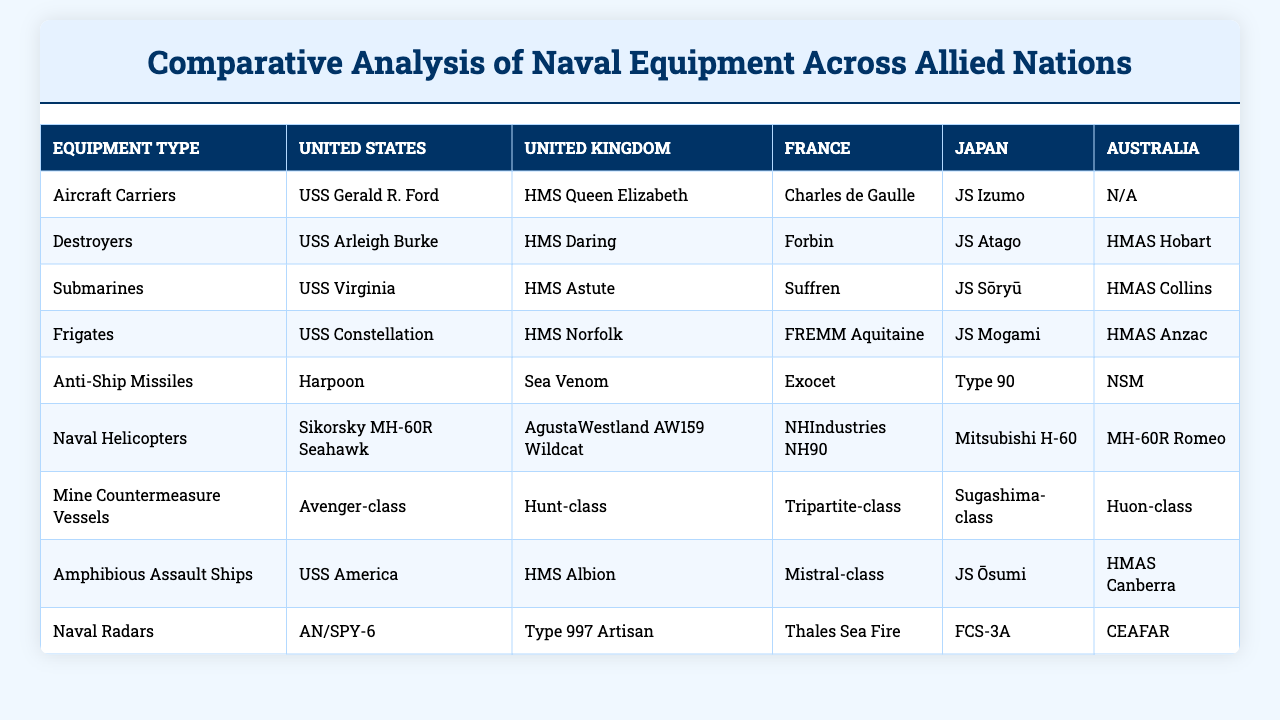What is the aircraft carrier of the United Kingdom? The table indicates that the United Kingdom's aircraft carrier is HMS Queen Elizabeth.
Answer: HMS Queen Elizabeth Which nation has the most types of destroyers listed? Each allied nation has one type of destroyer listed in the table, so there are no differences in the number of destroyers among the nations.
Answer: None (equal amount) Does Australia have an aircraft carrier? The table shows that Australia's entry for aircraft carriers is listed as N/A, indicating they do not possess one.
Answer: No What is the anti-ship missile used by France? Referring to the table, the anti-ship missile specified for France is Exocet.
Answer: Exocet Which country uses the USS Arleigh Burke? According to the information presented, the USS Arleigh Burke is associated with the United States.
Answer: United States Identify the helicopter utilized by Japan. The table lists the Mitsubishi H-60 as Japan's naval helicopter.
Answer: Mitsubishi H-60 Out of the listed nations, which has the most advanced radar system as per the table? The radar systems are different for each country, but each country's entry is listed in the table, and there is no standardized "advanced" measure provided. Thus, no single nation can be determined as having the most advanced radar system based solely on the names listed.
Answer: Cannot determine What is the difference in type of submarines between the United States and Australia? The United States has the USS Virginia as their submarine while Australia has HMAS Collins. Therefore, the difference lies in the specific model used, indicating diversity in submarine technology.
Answer: Different models If you add the number of ship types listed for each country, what will be the total? Each country has 8 types of naval equipment listed in the table, so the total will be 8 (types) x 5 (countries) = 40.
Answer: 40 Which nation has the largest amphibious assault ship? The table does not provide specific dimensions of the amphibious assault ships listed, preventing a definitive answer about which is the largest.
Answer: Cannot determine What can you infer about Australia’s naval capabilities in comparison to the United States regarding aircraft carriers? The table shows that Australia currently lacks an aircraft carrier (N/A) while the United States has the USS Gerald R. Ford, suggesting that the U.S. possesses a more robust capability in this category.
Answer: U.S. has stronger capability 